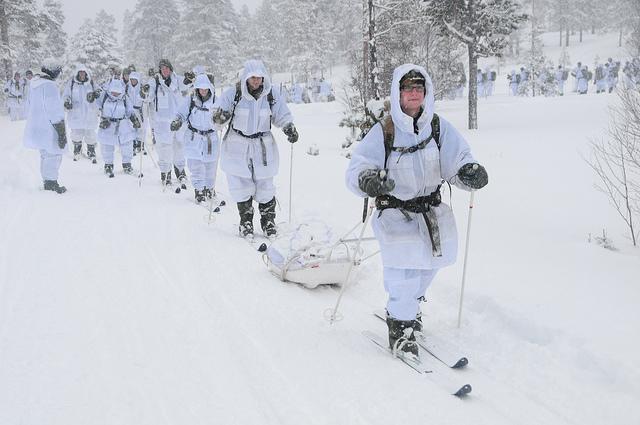How many people can you see?
Give a very brief answer. 8. 